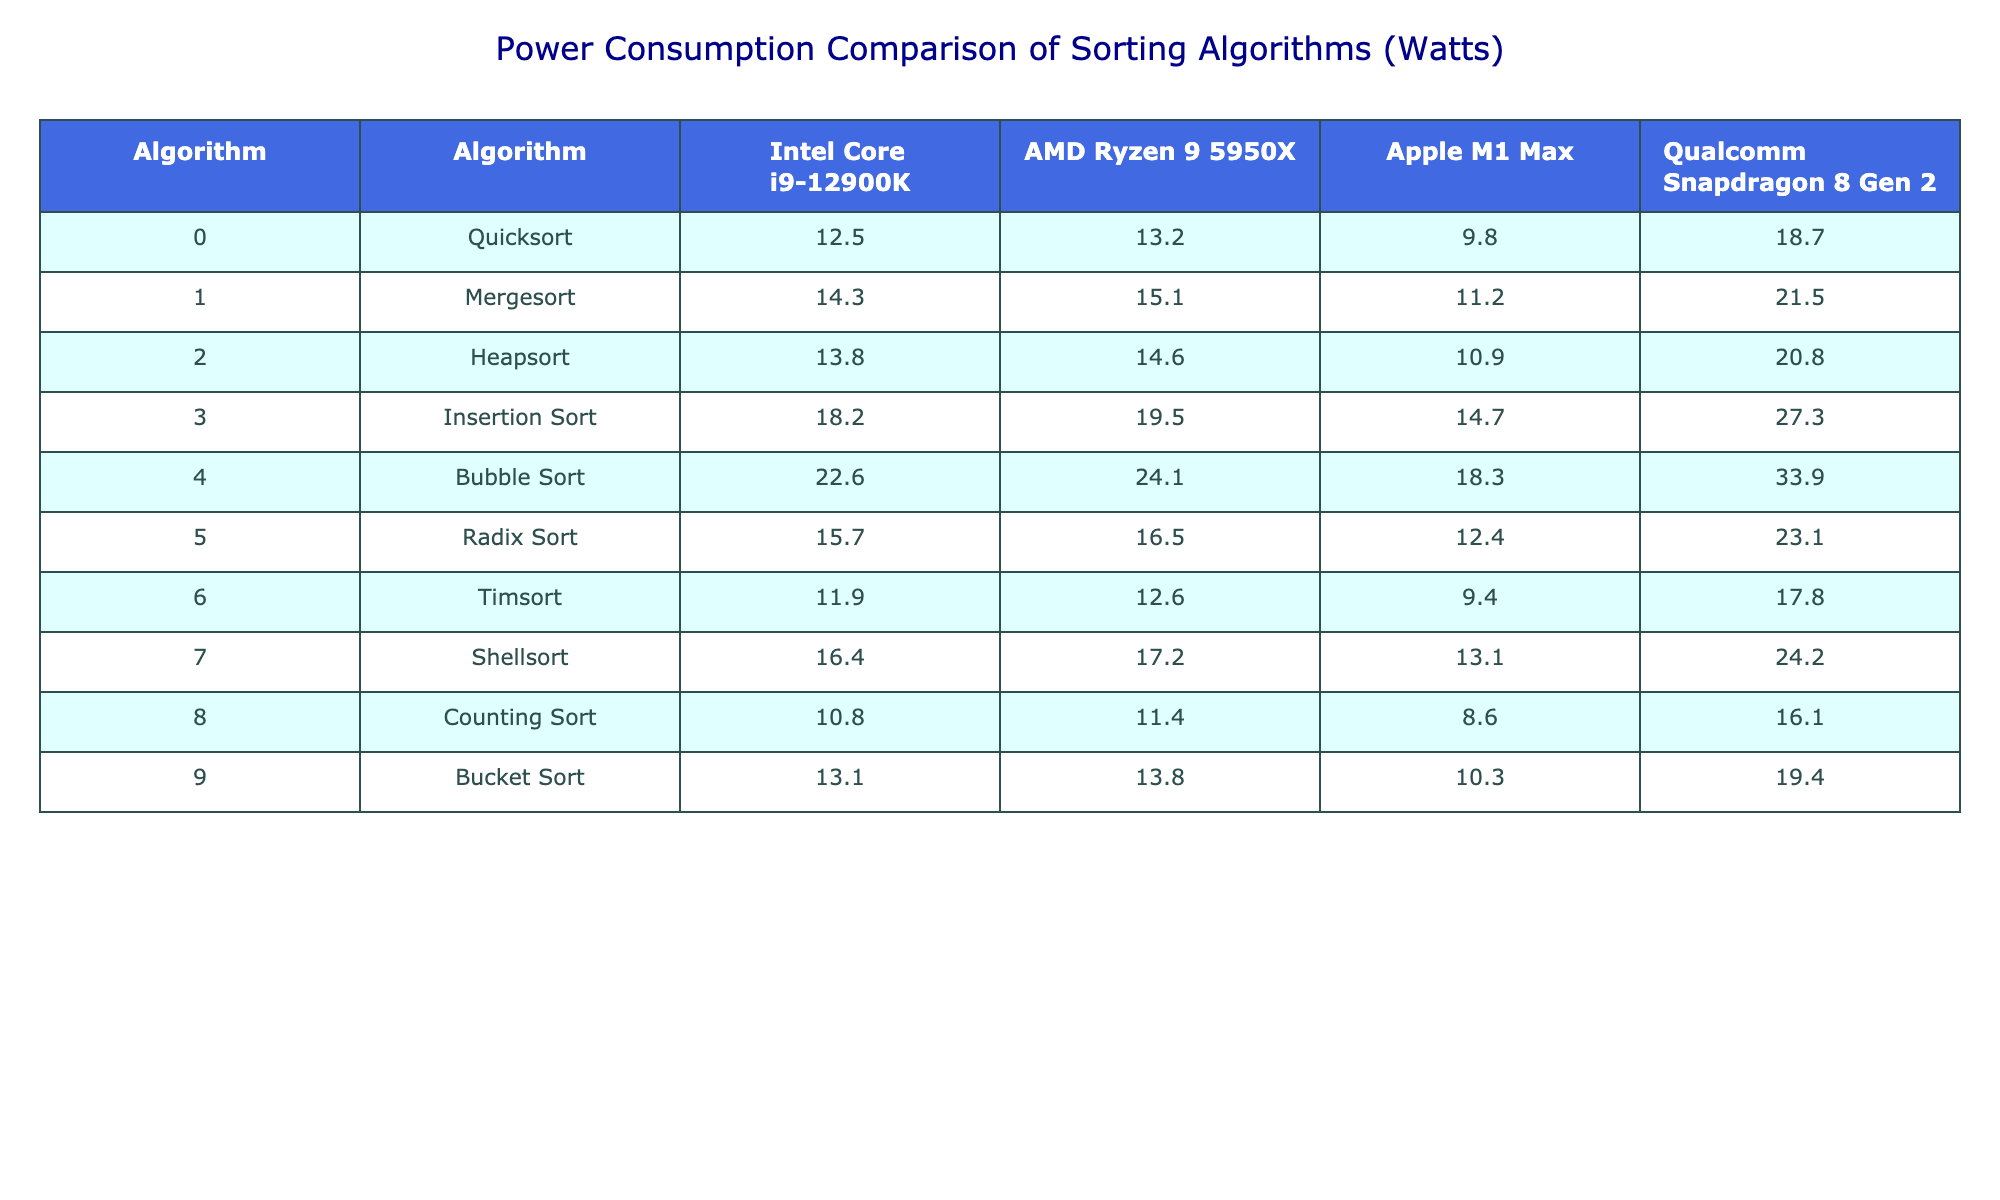What is the power consumption of Mergesort on the Apple M1 Max? The table shows that Mergesort consumes 11.2 Watts on the Apple M1 Max. This value can be directly retrieved from the corresponding cell under the Apple M1 Max column for the Mergesort row.
Answer: 11.2 Watts Which algorithm has the highest power consumption on the AMD Ryzen 9 5950X? Looking at the AMD Ryzen 9 5950X column, the algorithm with the highest value is Bubble Sort at 24.1 Watts. By scanning through the values listed under that column, it’s clear that no other algorithm exceeds this value.
Answer: Bubble Sort What is the difference in power consumption between Quicksort and Heapsort on the Intel Core i9-12900K? For Quicksort, the power consumption is 12.5 Watts, while Heapsort consumes 13.8 Watts on the Intel Core i9-12900K. The difference is calculated as 13.8 - 12.5 = 1.3 Watts.
Answer: 1.3 Watts Is the power consumption of Counting Sort lower than that of Timsort on the Qualcomm Snapdragon 8 Gen 2? The table indicates that Counting Sort uses 16.1 Watts, while Timsort uses 17.8 Watts. Therefore, Counting Sort does indeed have a lower power consumption.
Answer: Yes What is the average power consumption of all sorting algorithms on the Intel Core i9-12900K? To calculate the average, first sum all the power consumption values for the Intel Core i9-12900K: 12.5 + 14.3 + 13.8 + 18.2 + 22.6 + 15.7 + 11.9 + 16.4 + 10.8 + 13.1 =  133.9 Watts. There are 10 algorithms, so the average is 133.9 / 10 = 13.39 Watts.
Answer: 13.39 Watts Which CPU model has the lowest power consumption for Insertion Sort? In the Insertion Sort row, the power consumption values for the CPUs are Intel Core i9-12900K (18.2 Watts), AMD Ryzen 9 5950X (19.5 Watts), Apple M1 Max (14.7 Watts), and Qualcomm Snapdragon 8 Gen 2 (27.3 Watts). The lowest value is 14.7 Watts for the Apple M1 Max.
Answer: Apple M1 Max If we compare Bubble Sort and Radix Sort, which one consumes more power on the AMD Ryzen 9 5950X? On the AMD Ryzen 9 5950X, Bubble Sort has a power consumption of 24.1 Watts, while Radix Sort consumes 16.5 Watts. Since 24.1 > 16.5, Bubble Sort consumes more power.
Answer: Bubble Sort What is the total power consumption of Heapsort on all CPU models? The power consumption of Heapsort is as follows: Intel Core i9-12900K (13.8 Watts), AMD Ryzen 9 5950X (14.6 Watts), Apple M1 Max (10.9 Watts), and Qualcomm Snapdragon 8 Gen 2 (20.8 Watts). The total is 13.8 + 14.6 + 10.9 + 20.8 = 70.1 Watts.
Answer: 70.1 Watts How much more power does Timsort require compared to Counting Sort on the Intel Core i9-12900K? Timsort requires 11.9 Watts and Counting Sort requires 10.8 Watts on the Intel Core i9-12900K. The difference is 11.9 - 10.8 = 1.1 Watts.
Answer: 1.1 Watts Which algorithm is more power-efficient on the Apple M1 Max, Shellsort or Counting Sort? For the Apple M1 Max, Shellsort consumes 13.1 Watts while Counting Sort consumes 10.3 Watts. Since 10.3 < 13.1, Counting Sort is more power-efficient.
Answer: Counting Sort What is the power consumption trend across the algorithms for the Qualcomm Snapdragon 8 Gen 2? By reviewing the Qualcomm Snapdragon 8 Gen 2 column, we can see a general trend that the algorithms towards the bottom of the list (like Insertion Sort and Bubble Sort) have higher consumption values, while those at the top (like Counting Sort) consume less.
Answer: Increasing trend 